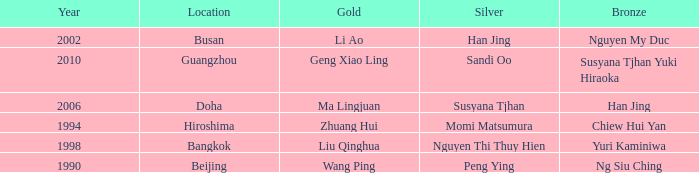What's the lowest Year with the Location of Bangkok? 1998.0. 